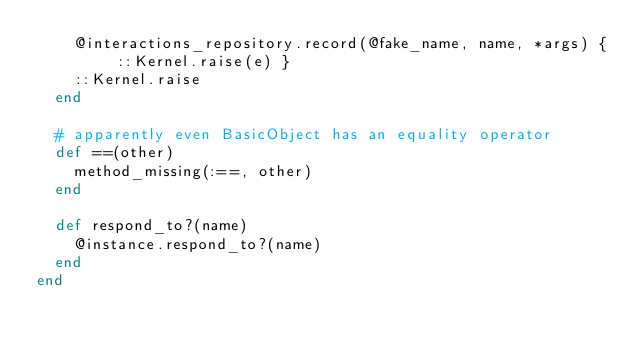<code> <loc_0><loc_0><loc_500><loc_500><_Ruby_>    @interactions_repository.record(@fake_name, name, *args) { ::Kernel.raise(e) }
    ::Kernel.raise
  end

  # apparently even BasicObject has an equality operator
  def ==(other)
    method_missing(:==, other)
  end

  def respond_to?(name)
    @instance.respond_to?(name)
  end
end

</code> 